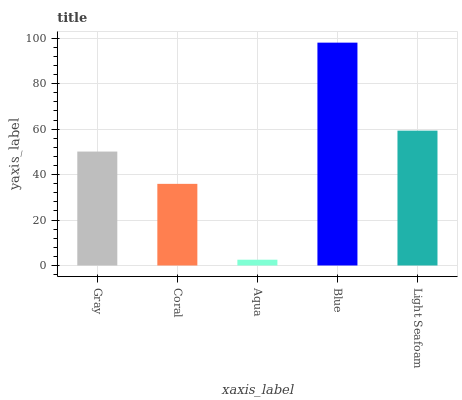Is Aqua the minimum?
Answer yes or no. Yes. Is Blue the maximum?
Answer yes or no. Yes. Is Coral the minimum?
Answer yes or no. No. Is Coral the maximum?
Answer yes or no. No. Is Gray greater than Coral?
Answer yes or no. Yes. Is Coral less than Gray?
Answer yes or no. Yes. Is Coral greater than Gray?
Answer yes or no. No. Is Gray less than Coral?
Answer yes or no. No. Is Gray the high median?
Answer yes or no. Yes. Is Gray the low median?
Answer yes or no. Yes. Is Aqua the high median?
Answer yes or no. No. Is Blue the low median?
Answer yes or no. No. 